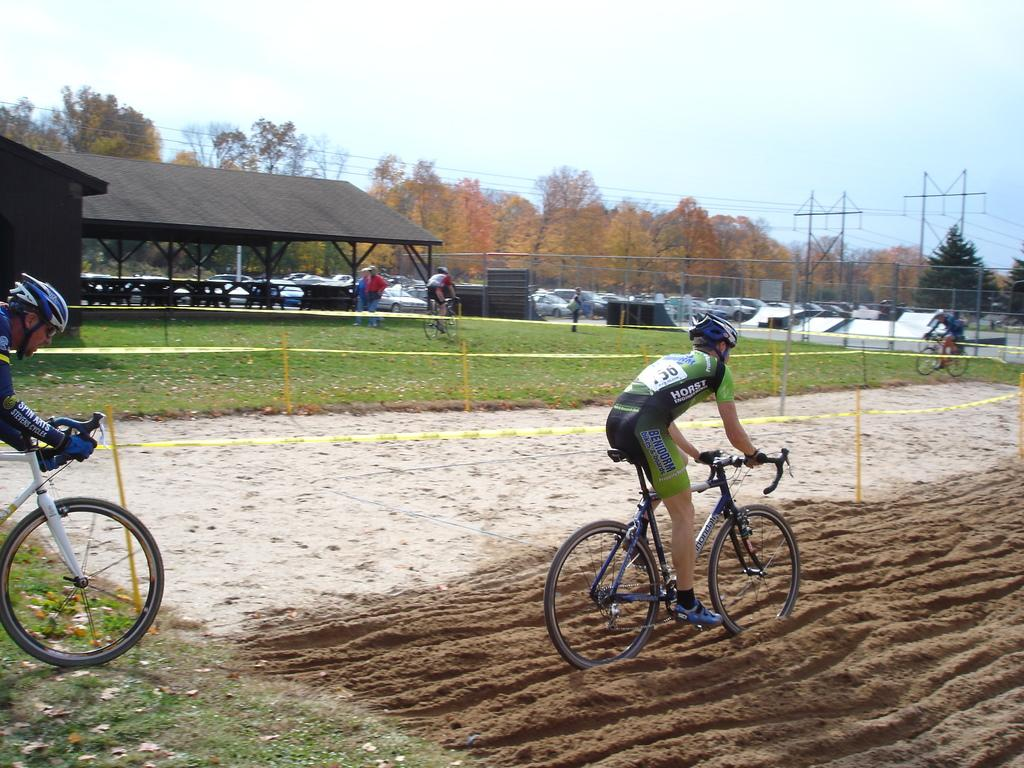What are the two people in the image doing? The two people in the image are riding bicycles. What safety precaution are the people taking while riding bicycles? The people are wearing helmets. What can be seen in the background of the image? There are people, a shed, vehicles, towers with wires, trees, and the sky visible in the background of the image. What type of power is being generated by the dogs in the image? There are no dogs present in the image, so no power is being generated by them. 